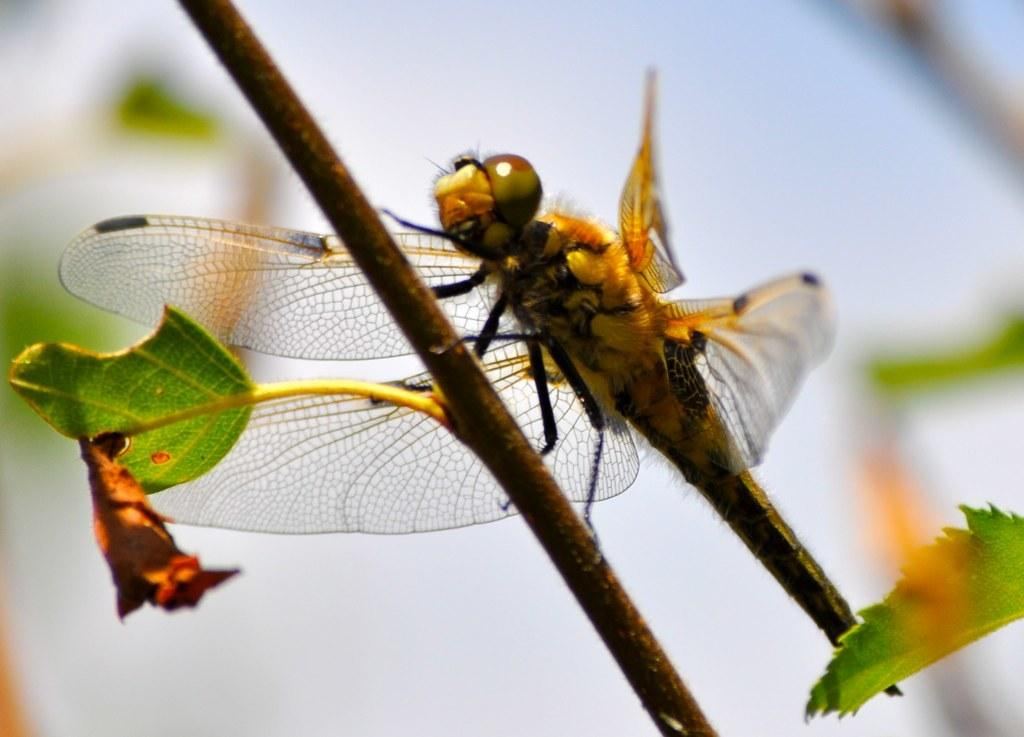What is present on the plant stem in the image? There is an insect on the plant stem in the image. What can be seen on the plant besides the insect? There are leaves visible in the image. Can you describe the background of the image? The background of the image is blurred. How many eyes can be seen on the donkey in the image? There is no donkey present in the image; it features a plant with an insect and leaves. What type of cord is used to hang the plant in the image? There is no cord visible in the image; it only shows a plant with an insect and leaves. 